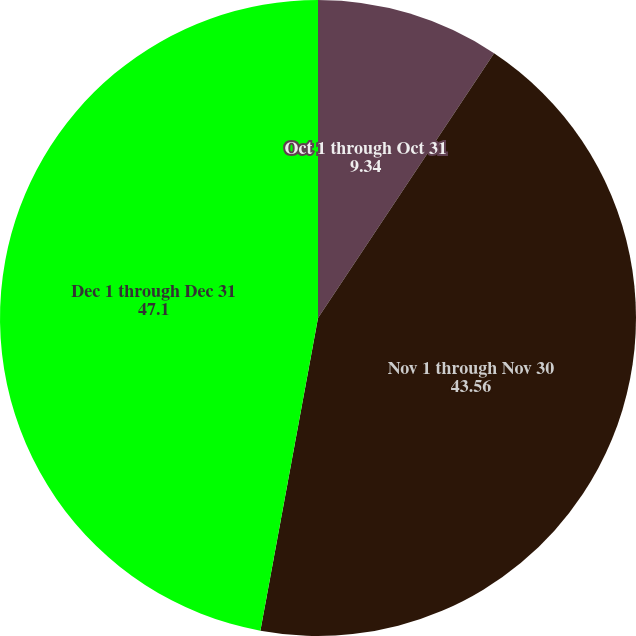Convert chart to OTSL. <chart><loc_0><loc_0><loc_500><loc_500><pie_chart><fcel>Oct 1 through Oct 31<fcel>Nov 1 through Nov 30<fcel>Dec 1 through Dec 31<nl><fcel>9.34%<fcel>43.56%<fcel>47.1%<nl></chart> 